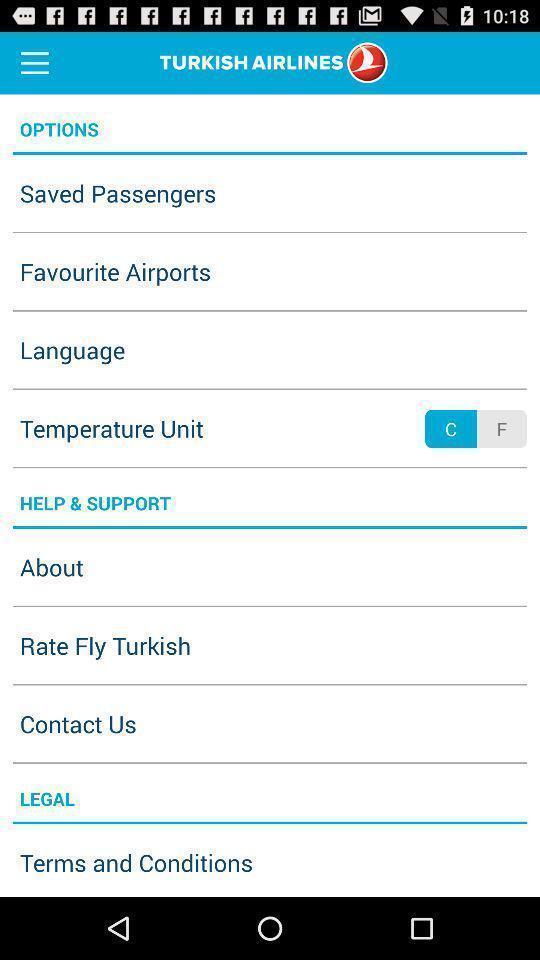Explain the elements present in this screenshot. Settings page displaying various options on a travel app. 